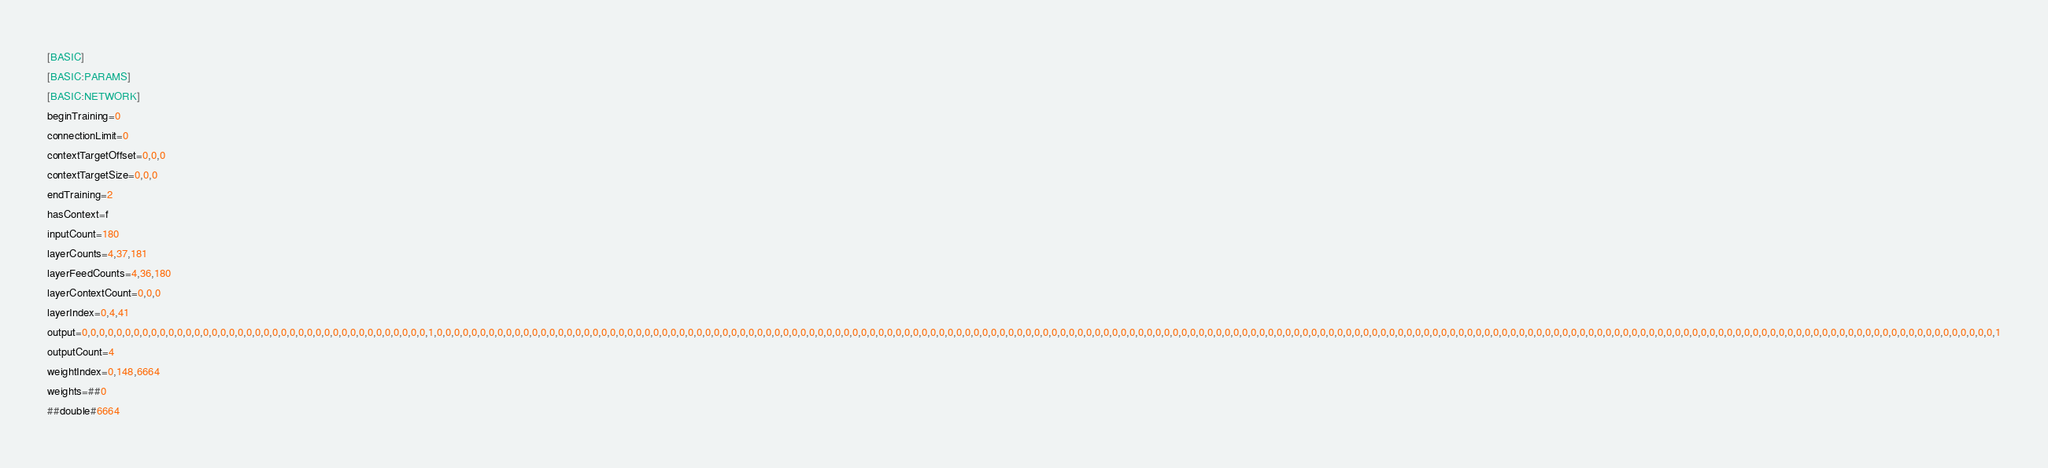<code> <loc_0><loc_0><loc_500><loc_500><_OCaml_>[BASIC]
[BASIC:PARAMS]
[BASIC:NETWORK]
beginTraining=0
connectionLimit=0
contextTargetOffset=0,0,0
contextTargetSize=0,0,0
endTraining=2
hasContext=f
inputCount=180
layerCounts=4,37,181
layerFeedCounts=4,36,180
layerContextCount=0,0,0
layerIndex=0,4,41
output=0,0,0,0,0,0,0,0,0,0,0,0,0,0,0,0,0,0,0,0,0,0,0,0,0,0,0,0,0,0,0,0,0,0,0,0,0,0,0,0,1,0,0,0,0,0,0,0,0,0,0,0,0,0,0,0,0,0,0,0,0,0,0,0,0,0,0,0,0,0,0,0,0,0,0,0,0,0,0,0,0,0,0,0,0,0,0,0,0,0,0,0,0,0,0,0,0,0,0,0,0,0,0,0,0,0,0,0,0,0,0,0,0,0,0,0,0,0,0,0,0,0,0,0,0,0,0,0,0,0,0,0,0,0,0,0,0,0,0,0,0,0,0,0,0,0,0,0,0,0,0,0,0,0,0,0,0,0,0,0,0,0,0,0,0,0,0,0,0,0,0,0,0,0,0,0,0,0,0,0,0,0,0,0,0,0,0,0,0,0,0,0,0,0,0,0,0,0,0,0,0,0,0,0,0,0,0,0,0,0,0,0,0,0,0,0,0,0,0,0,0,1
outputCount=4
weightIndex=0,148,6664
weights=##0
##double#6664</code> 